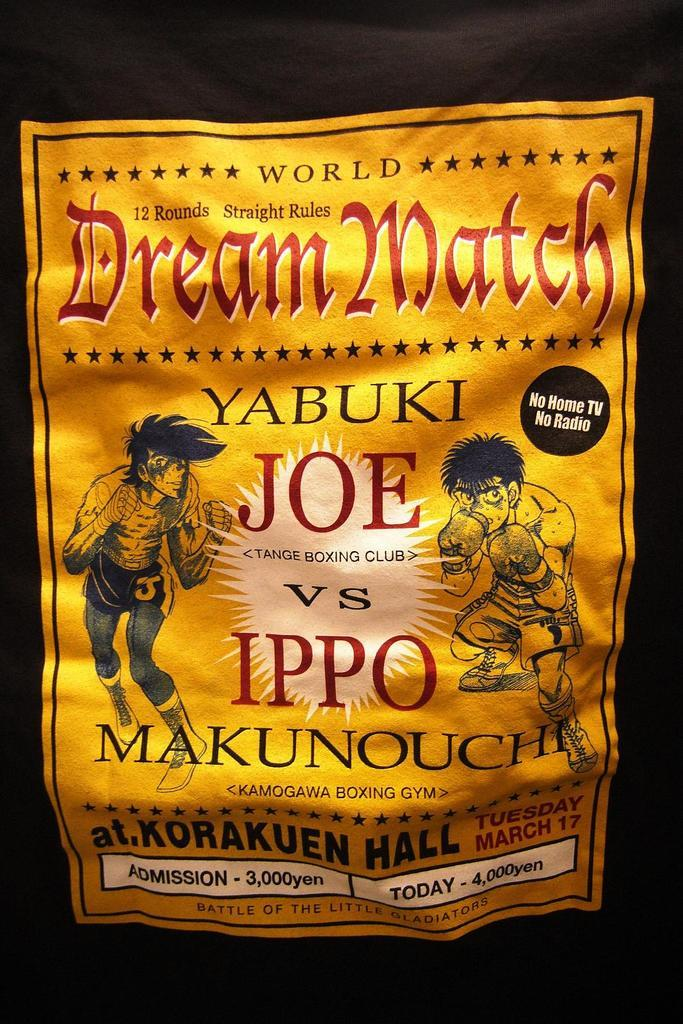<image>
Write a terse but informative summary of the picture. Poster that says "Dream Match" which has a fight between Joe vs Ippo. 